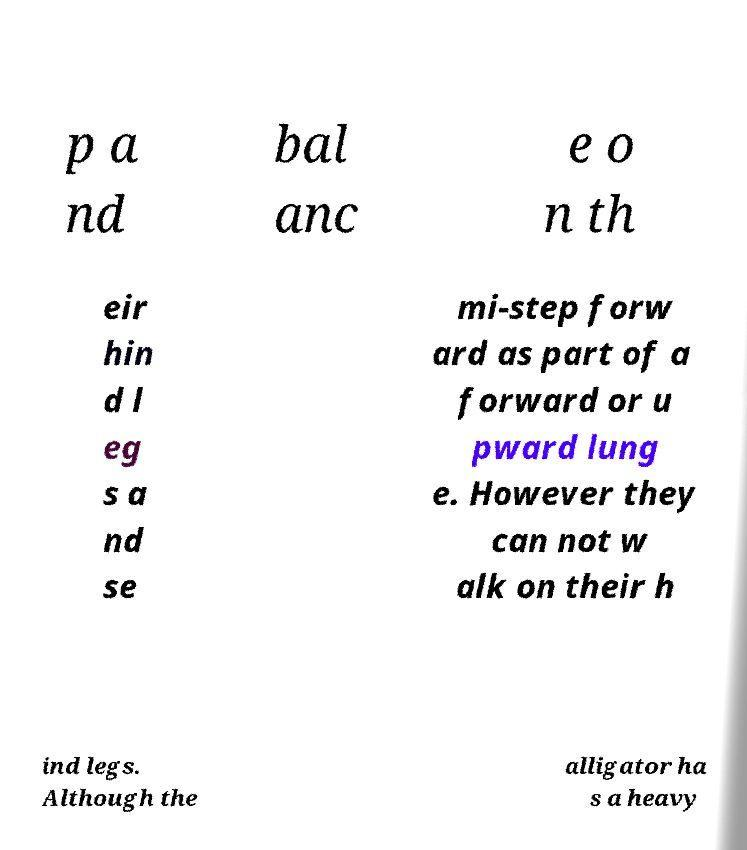I need the written content from this picture converted into text. Can you do that? p a nd bal anc e o n th eir hin d l eg s a nd se mi-step forw ard as part of a forward or u pward lung e. However they can not w alk on their h ind legs. Although the alligator ha s a heavy 